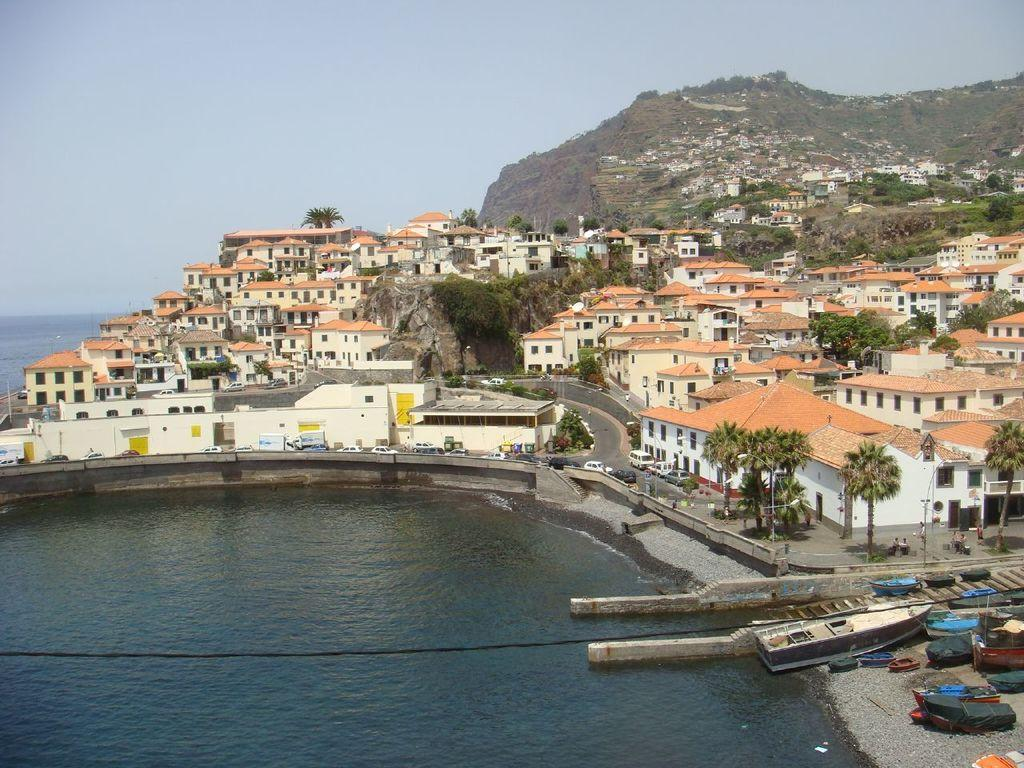What type of vehicles can be seen in the image? There are vehicles in the image, but the specific types are not mentioned in the facts. What is the primary setting of the image? The image features boats, water, houses, trees, vehicles, people, a mountain, and the sky, suggesting a waterfront or coastal area. Can you describe the natural elements in the image? The image includes water, trees, and a mountain. What is the weather like in the image? The sky is visible in the background of the image, but the weather cannot be determined from the facts provided. What type of pot is being used for digestion in the image? There is no pot or mention of digestion in the image; it features boats, water, houses, trees, vehicles, people, a mountain, and the sky. 